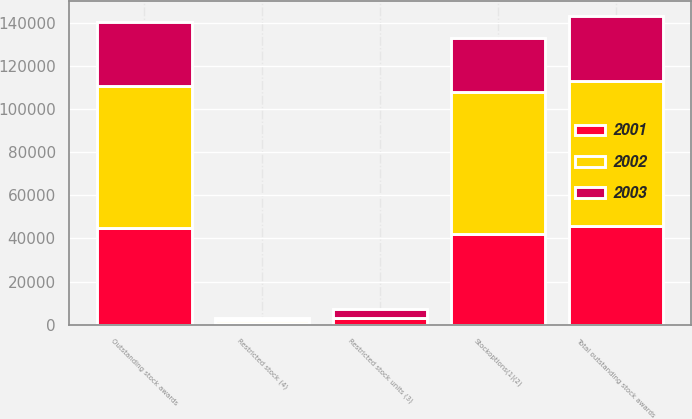<chart> <loc_0><loc_0><loc_500><loc_500><stacked_bar_chart><ecel><fcel>Stockoptions(1)(2)<fcel>Restricted stock units (3)<fcel>Outstanding stock awards<fcel>Restricted stock (4)<fcel>Total outstanding stock awards<nl><fcel>2003<fcel>24961<fcel>4410<fcel>29371<fcel>790<fcel>30161<nl><fcel>2001<fcel>42005<fcel>2935<fcel>44940<fcel>1011<fcel>45951<nl><fcel>2002<fcel>65950<fcel>20<fcel>65970<fcel>1113<fcel>67083<nl></chart> 